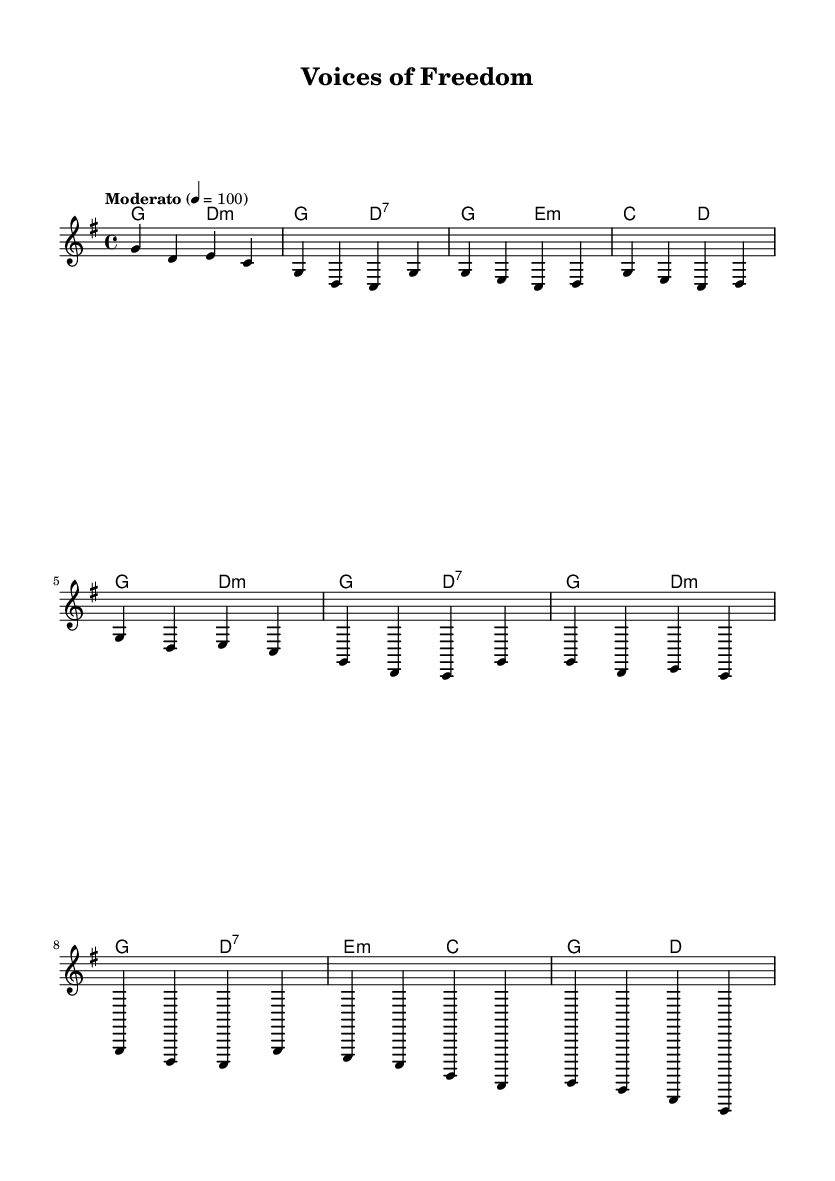What is the key signature of this music? The key signature indicated by the initial "g" suggests that the piece is in G major. G major has one sharp (F#), which is the standard for works in this key.
Answer: G major What is the time signature of this music? The time signature shown as "4/4" indicates that there are four beats in each measure and the quarter note gets one beat, which is common in folk music for its straightforward rhythm.
Answer: 4/4 What is the tempo marking of this piece? The tempo is indicated as "Moderato" with a metronome marking of 100 beats per minute, which defines the pacing of the piece, suggesting a moderate speed suitable for folk anthems.
Answer: Moderato 4 = 100 How many measures are there in the chorus section? By counting the sections labeled and their corresponding notes in the sheet music, the chorus has eight measures. This is typical for the repeated structure often found in folk anthems that encourage participation.
Answer: 8 What type of chords are used in the bridge? The chords in the bridge section are identified as minor (e:min) and major (c) chords through the chord symbols written above the melody, reflecting the emotional character often found in folk music during a reflective moment.
Answer: Minor and Major What is the main theme of this folk anthem? The title "Voices of Freedom" suggests that the anthem's main theme revolves around celebrating liberation and democracy, a common focus in folk music associated with social change and revolutionary movements.
Answer: Freedom What artistic message does the repetition in the chorus convey? The repetition of musical phrases in the chorus serves to emphasize key themes or messages of the song, reinforcing unity and collective participation, which are vital in democratic movements celebrated in folk anthems.
Answer: Emphasizes unity 